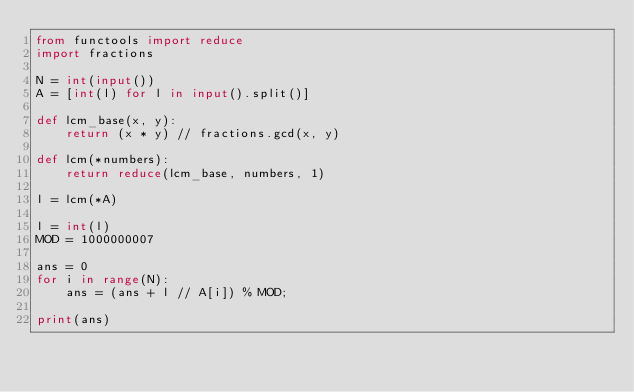<code> <loc_0><loc_0><loc_500><loc_500><_Python_>from functools import reduce
import fractions

N = int(input())
A = [int(l) for l in input().split()]

def lcm_base(x, y):
    return (x * y) // fractions.gcd(x, y)

def lcm(*numbers):
    return reduce(lcm_base, numbers, 1)

l = lcm(*A)

l = int(l)
MOD = 1000000007

ans = 0
for i in range(N):
    ans = (ans + l // A[i]) % MOD;

print(ans)
</code> 